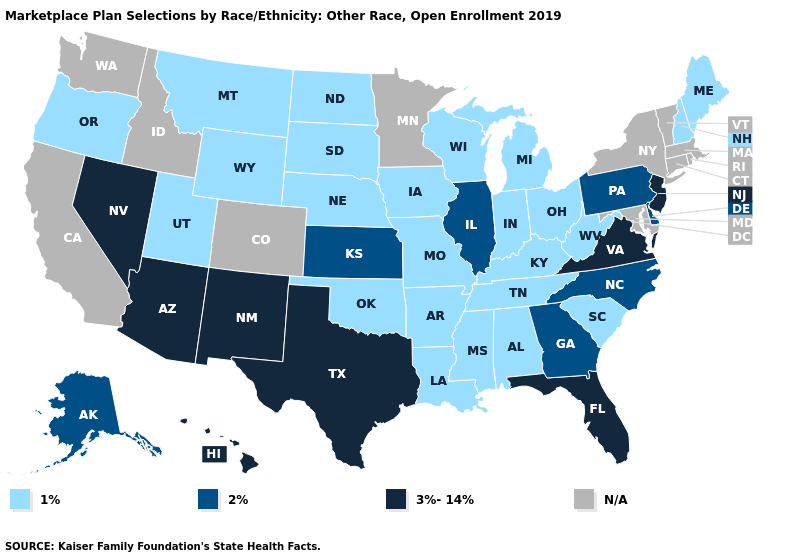What is the value of Kentucky?
Quick response, please. 1%. What is the value of California?
Answer briefly. N/A. Among the states that border Kentucky , does West Virginia have the highest value?
Concise answer only. No. Name the states that have a value in the range 1%?
Answer briefly. Alabama, Arkansas, Indiana, Iowa, Kentucky, Louisiana, Maine, Michigan, Mississippi, Missouri, Montana, Nebraska, New Hampshire, North Dakota, Ohio, Oklahoma, Oregon, South Carolina, South Dakota, Tennessee, Utah, West Virginia, Wisconsin, Wyoming. Which states have the lowest value in the USA?
Give a very brief answer. Alabama, Arkansas, Indiana, Iowa, Kentucky, Louisiana, Maine, Michigan, Mississippi, Missouri, Montana, Nebraska, New Hampshire, North Dakota, Ohio, Oklahoma, Oregon, South Carolina, South Dakota, Tennessee, Utah, West Virginia, Wisconsin, Wyoming. Does the map have missing data?
Give a very brief answer. Yes. What is the lowest value in the Northeast?
Keep it brief. 1%. Name the states that have a value in the range 2%?
Quick response, please. Alaska, Delaware, Georgia, Illinois, Kansas, North Carolina, Pennsylvania. Which states have the lowest value in the USA?
Give a very brief answer. Alabama, Arkansas, Indiana, Iowa, Kentucky, Louisiana, Maine, Michigan, Mississippi, Missouri, Montana, Nebraska, New Hampshire, North Dakota, Ohio, Oklahoma, Oregon, South Carolina, South Dakota, Tennessee, Utah, West Virginia, Wisconsin, Wyoming. Name the states that have a value in the range N/A?
Answer briefly. California, Colorado, Connecticut, Idaho, Maryland, Massachusetts, Minnesota, New York, Rhode Island, Vermont, Washington. Does New Jersey have the lowest value in the USA?
Keep it brief. No. Does Alaska have the lowest value in the USA?
Answer briefly. No. Does Mississippi have the lowest value in the South?
Keep it brief. Yes. Among the states that border Florida , which have the highest value?
Be succinct. Georgia. What is the value of Idaho?
Answer briefly. N/A. 